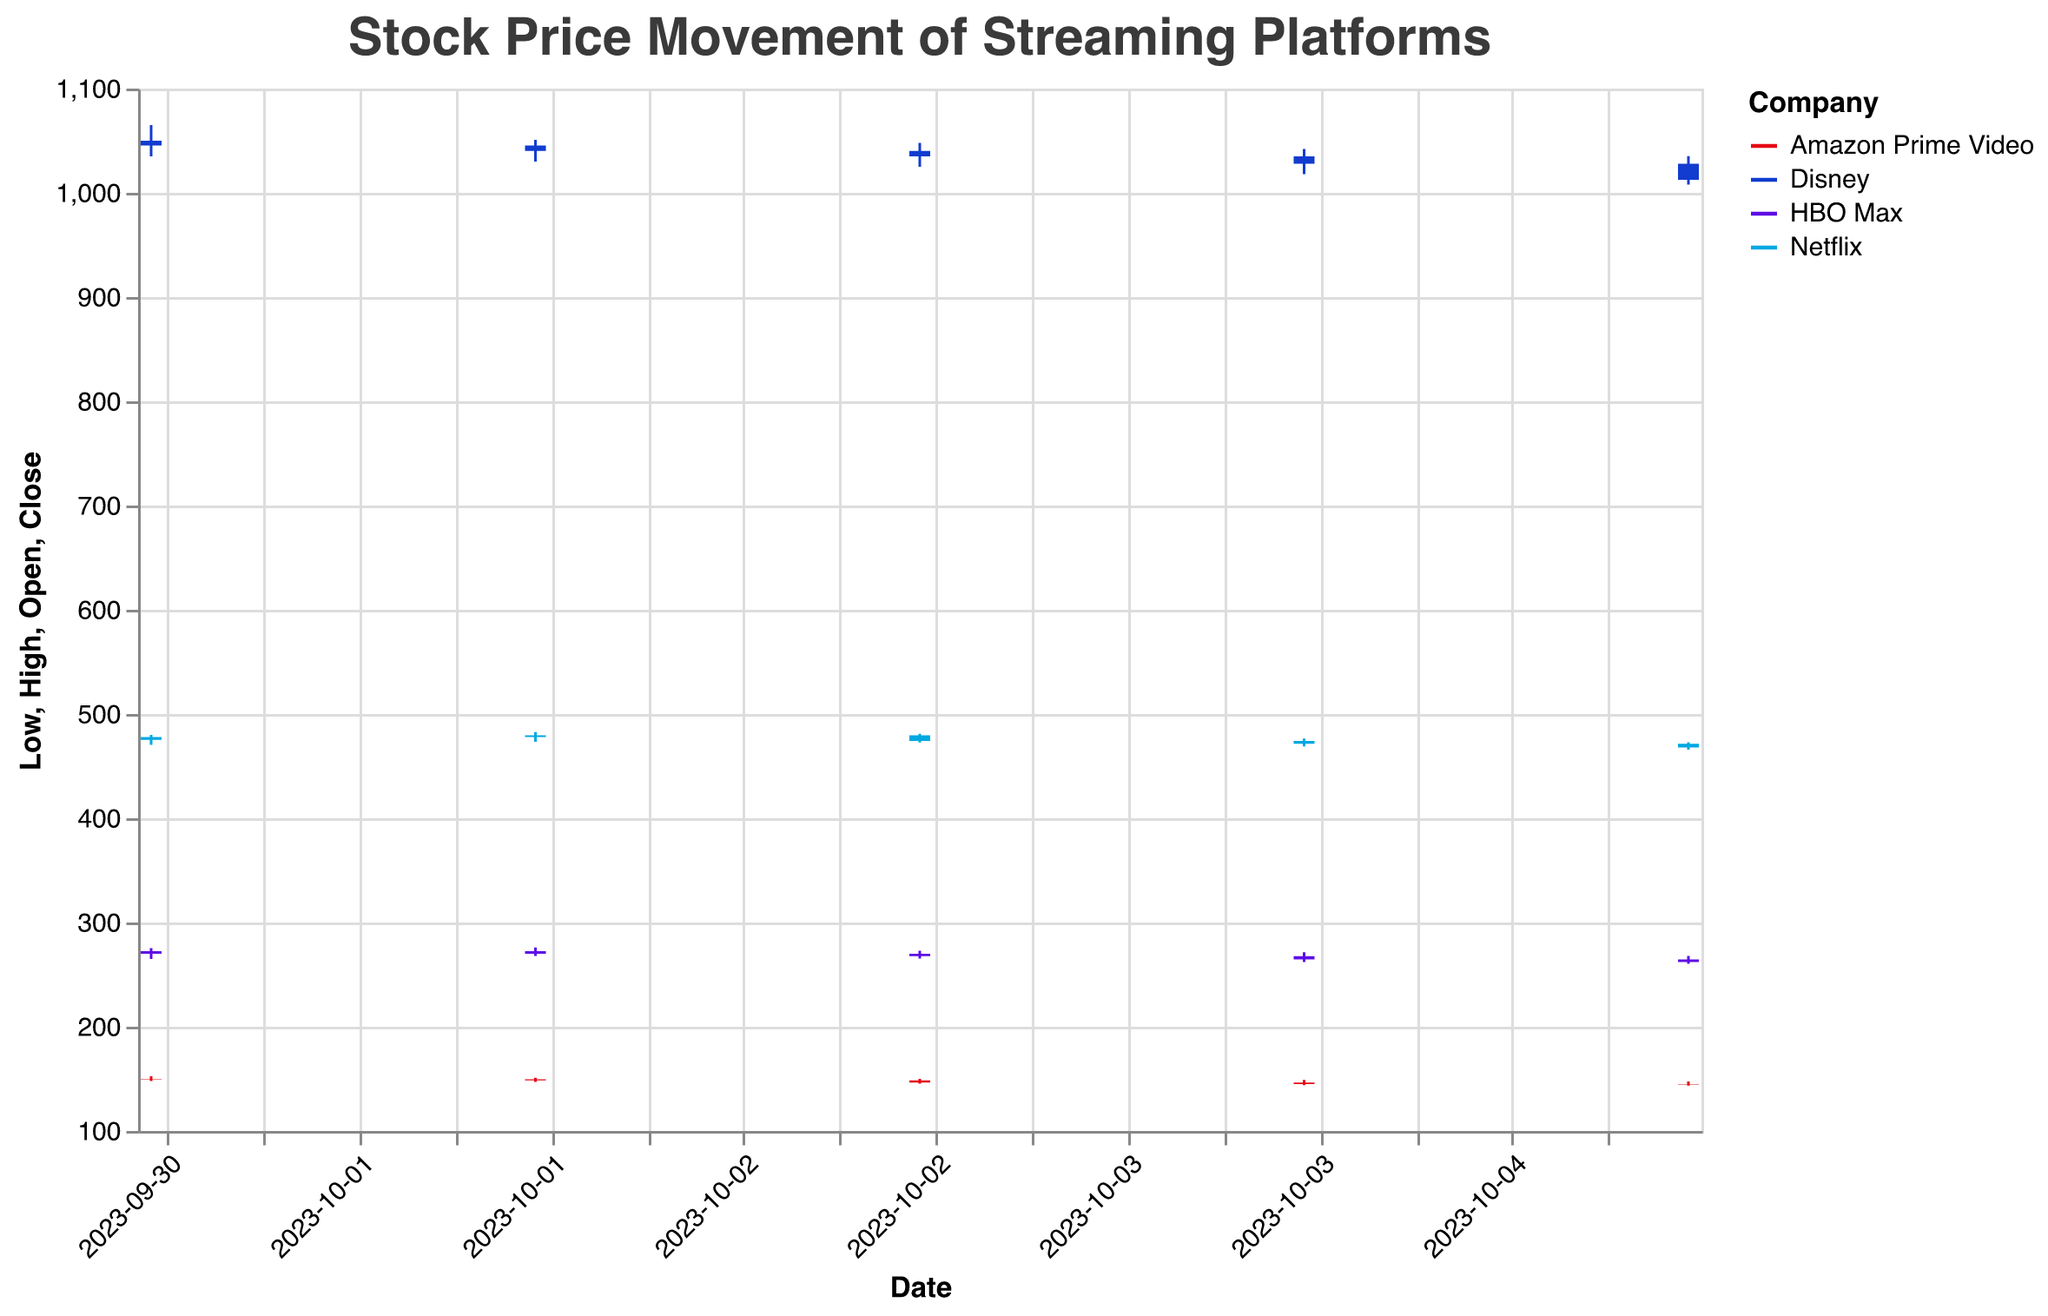What is the title of the chart? The title can be found at the top of the chart. It is generally very prominent and describes what the chart is about.
Answer: Stock Price Movement of Streaming Platforms Which stock had the highest closing price on October 1, 2023? To find this, look at the closing prices for all companies on October 1, 2023. Compare the closing prices: Netflix (478.00), Disney (1045.50), HBO Max (272.50), and Amazon Prime Video (149.50).
Answer: Disney On which date did Netflix experience its lowest closing price? Find the closing prices for Netflix across all dates: 478.00 (Oct 1), 479.50 (Oct 2), 474.25 (Oct 3), 471.50 (Oct 4), and 468.00 (Oct 5). The lowest closing price is on October 5, 2023.
Answer: October 5, 2023 How many companies are represented in the chart? The names of the companies are associated with the data points and are color-coded. Count the unique company names.
Answer: 4 Compare the closing prices for HBO Max on October 1 and October 5, 2023. Which date had the higher closing price? HBO Max's closing prices are 272.50 (Oct 1) and 262.00 (Oct 5). Compare these values.
Answer: October 1, 2023 What was the volume of trades for Amazon Prime Video on October 2, 2023? Look for the volume data for Amazon Prime Video on October 2, 2023. The volume is 3,600,000.
Answer: 3,600,000 What is the trend in Disney's closing prices from October 1 to October 5, 2023? Observe Disney's closing prices: 1045.50 (Oct 1), 1040.25 (Oct 2), 1035.00 (Oct 3), 1028.00 (Oct 4), and 1012.50 (Oct 5). Notice that the prices decrease each day.
Answer: Decreasing Calculate the average closing price for all companies on October 3, 2023. Sum the closing prices for all companies on October 3, 2023: Netflix (474.25), Disney (1035.00), HBO Max (267.75), Amazon Prime Video (146.50). The total is 474.25 + 1035.00 + 267.75 + 146.50 = 1923.50. There are 4 companies, so the average is 1923.50 / 4.
Answer: 480.88 Which company had the least variation in high and low prices on October 2, 2023? Calculate the difference between high and low prices for each company on October 2, 2023: Netflix (9.50), Disney (20.75), HBO Max (8.00), and Amazon Prime Video (4.00). The lowest difference is for Amazon Prime Video.
Answer: Amazon Prime Video 